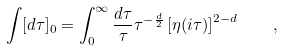Convert formula to latex. <formula><loc_0><loc_0><loc_500><loc_500>\int [ d \tau ] _ { 0 } = \int _ { 0 } ^ { \infty } \frac { d \tau } { \tau } \tau ^ { - \frac { d } { 2 } } \left [ \eta ( i \tau ) \right ] ^ { 2 - d } \quad ,</formula> 